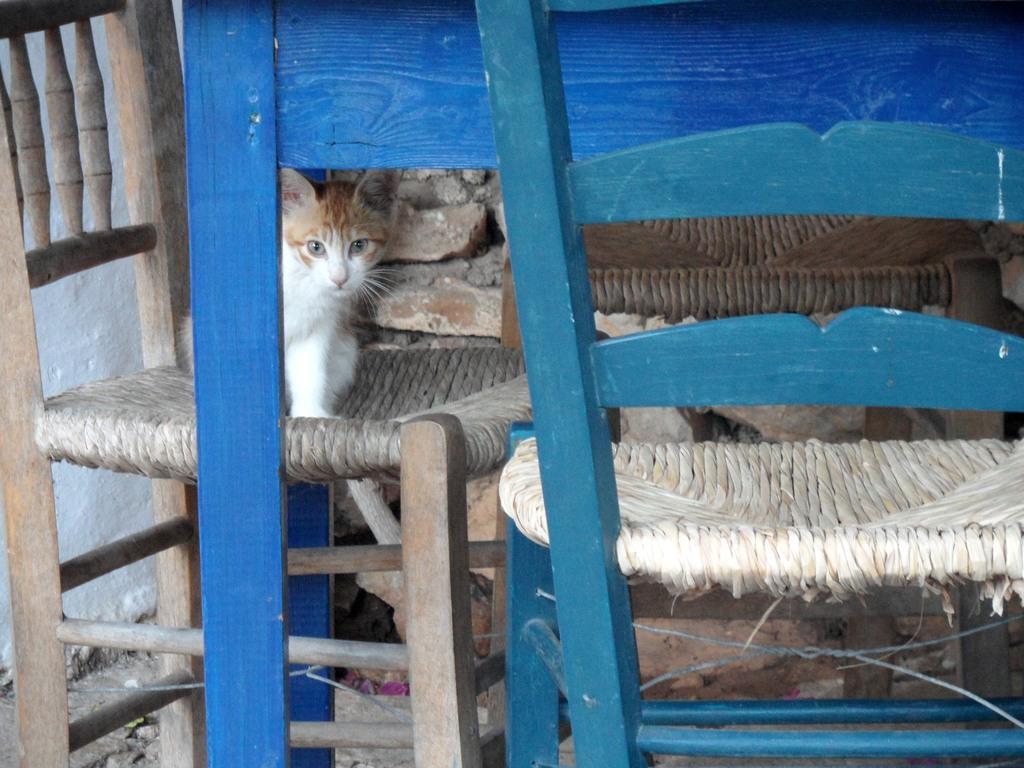In one or two sentences, can you explain what this image depicts? In this image there is a cat standing on a chair, the cat is staring, beside the cat there is another chair. 